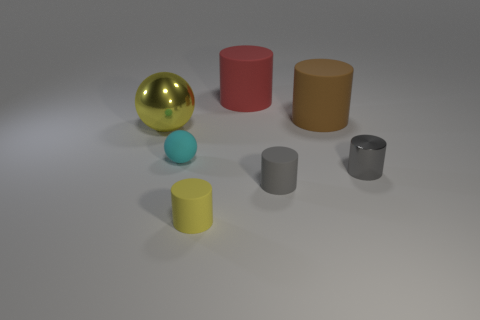Subtract all big brown cylinders. How many cylinders are left? 4 Subtract 2 cylinders. How many cylinders are left? 3 Subtract all brown cylinders. How many cylinders are left? 4 Subtract all red cylinders. Subtract all cyan blocks. How many cylinders are left? 4 Subtract all cylinders. How many objects are left? 2 Add 1 small gray shiny cylinders. How many objects exist? 8 Add 6 big yellow metal objects. How many big yellow metal objects are left? 7 Add 2 tiny rubber cylinders. How many tiny rubber cylinders exist? 4 Subtract 0 blue spheres. How many objects are left? 7 Subtract all big blue metallic things. Subtract all large matte objects. How many objects are left? 5 